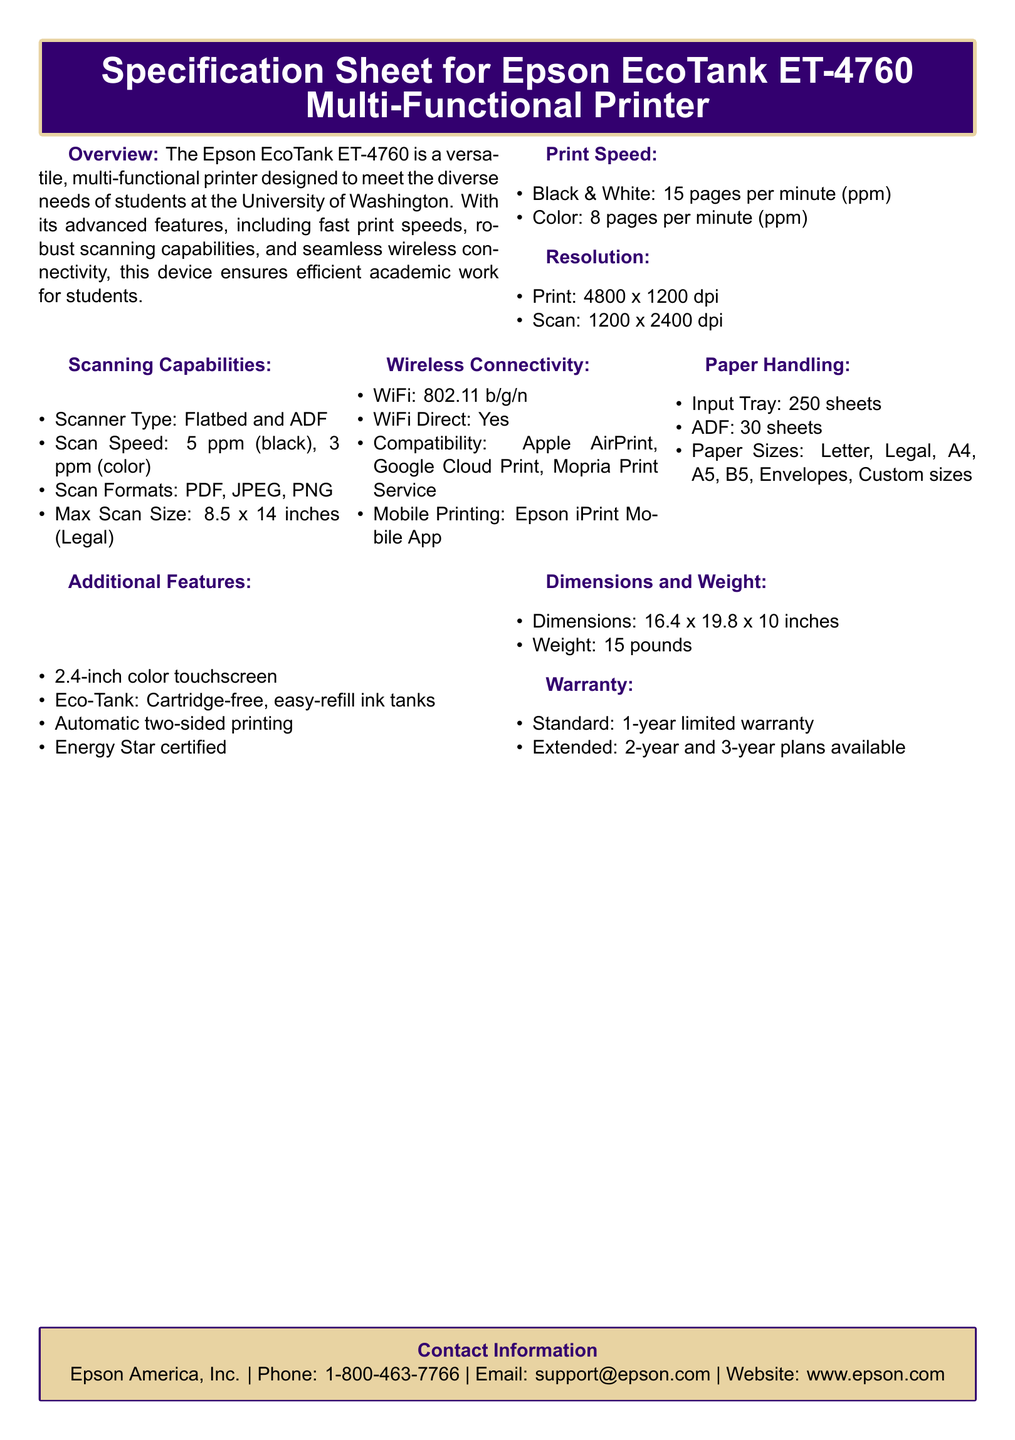What is the black and white print speed? The black and white print speed is listed in the document as 15 pages per minute.
Answer: 15 pages per minute What is the maximum scan size? The maximum scan size is specified in the document as 8.5 x 14 inches.
Answer: 8.5 x 14 inches What types of mobile printing are supported? The document mentions compatibility with Apple AirPrint, Google Cloud Print, and Mopria Print Service as mobile printing options.
Answer: Apple AirPrint, Google Cloud Print, Mopria Print Service How many sheets can the input tray hold? The input tray capacity is stated as 250 sheets in the document.
Answer: 250 sheets What is the weight of the printer? The document specifies the weight of the printer as 15 pounds.
Answer: 15 pounds What scanning capability is mentioned for color? The scan speed for color is mentioned in the document as 3 pages per minute.
Answer: 3 pages per minute What is the standard warranty period? The standard warranty period is stated as 1-year limited warranty in the document.
Answer: 1-year limited warranty What type of printer is the Epson EcoTank ET-4760 described as? The document describes it as a multi-functional printer designed for students.
Answer: Multi-functional printer What feature allows for automatic printing on both sides? The document states that the printer has automatic two-sided printing as a feature.
Answer: Automatic two-sided printing 